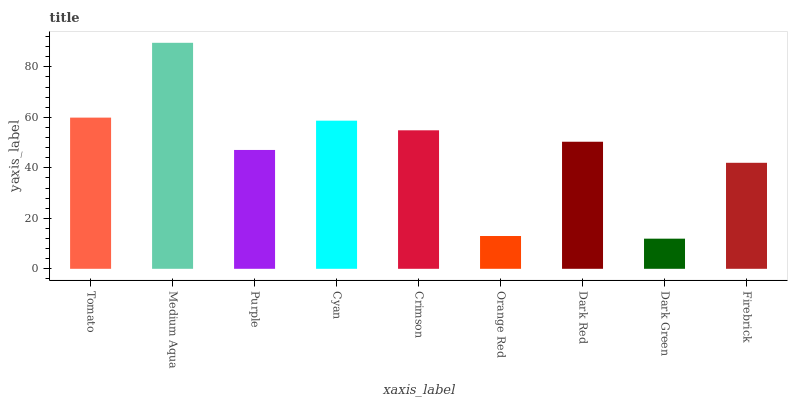Is Dark Green the minimum?
Answer yes or no. Yes. Is Medium Aqua the maximum?
Answer yes or no. Yes. Is Purple the minimum?
Answer yes or no. No. Is Purple the maximum?
Answer yes or no. No. Is Medium Aqua greater than Purple?
Answer yes or no. Yes. Is Purple less than Medium Aqua?
Answer yes or no. Yes. Is Purple greater than Medium Aqua?
Answer yes or no. No. Is Medium Aqua less than Purple?
Answer yes or no. No. Is Dark Red the high median?
Answer yes or no. Yes. Is Dark Red the low median?
Answer yes or no. Yes. Is Purple the high median?
Answer yes or no. No. Is Orange Red the low median?
Answer yes or no. No. 